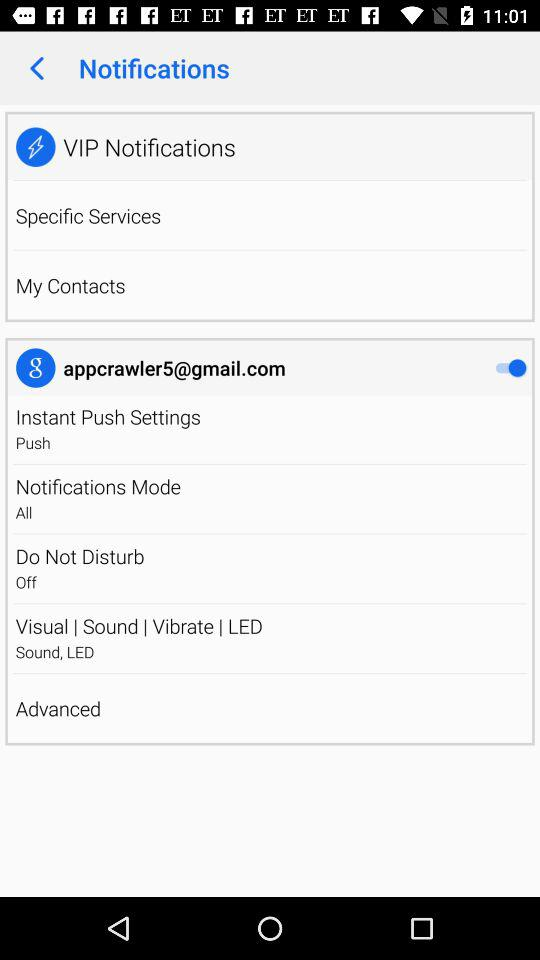What is the email address? The email address is appcrawler5@gmail.com. 